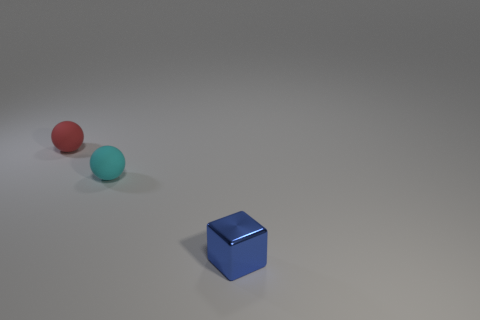Add 1 tiny red rubber objects. How many objects exist? 4 Subtract all balls. How many objects are left? 1 Subtract 1 cyan spheres. How many objects are left? 2 Subtract all tiny cyan matte things. Subtract all cyan matte objects. How many objects are left? 1 Add 1 metal things. How many metal things are left? 2 Add 2 cyan balls. How many cyan balls exist? 3 